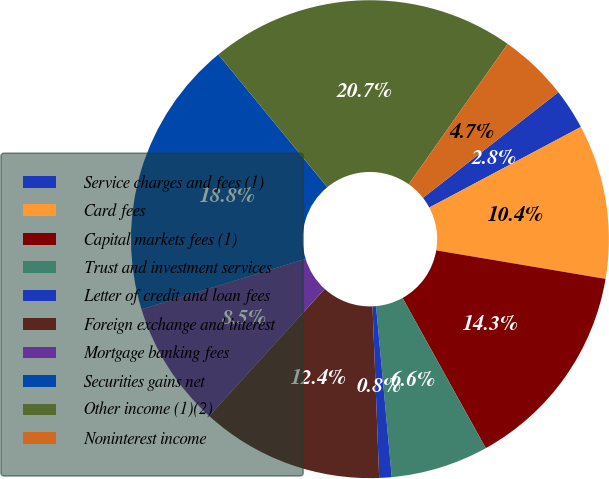Convert chart to OTSL. <chart><loc_0><loc_0><loc_500><loc_500><pie_chart><fcel>Service charges and fees (1)<fcel>Card fees<fcel>Capital markets fees (1)<fcel>Trust and investment services<fcel>Letter of credit and loan fees<fcel>Foreign exchange and interest<fcel>Mortgage banking fees<fcel>Securities gains net<fcel>Other income (1)(2)<fcel>Noninterest income<nl><fcel>2.76%<fcel>10.44%<fcel>14.29%<fcel>6.6%<fcel>0.84%<fcel>12.36%<fcel>8.52%<fcel>18.8%<fcel>20.72%<fcel>4.68%<nl></chart> 